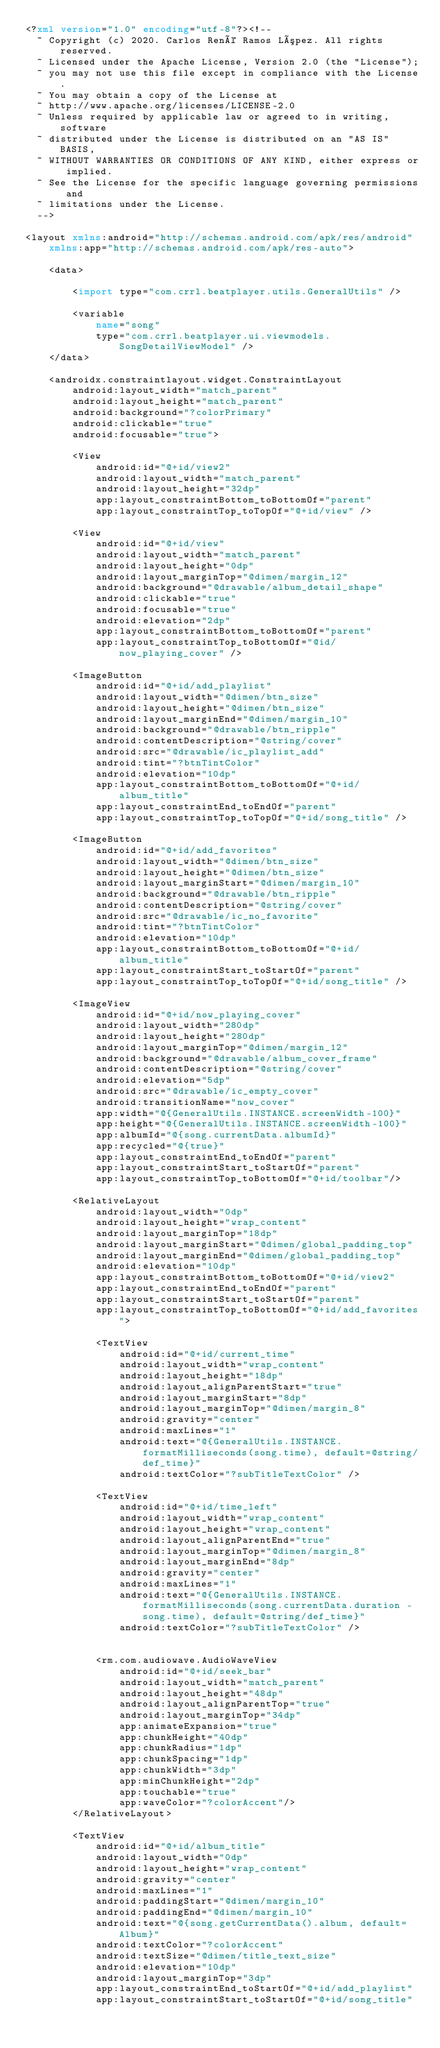Convert code to text. <code><loc_0><loc_0><loc_500><loc_500><_XML_><?xml version="1.0" encoding="utf-8"?><!--
  ~ Copyright (c) 2020. Carlos René Ramos López. All rights reserved.
  ~ Licensed under the Apache License, Version 2.0 (the "License");
  ~ you may not use this file except in compliance with the License.
  ~ You may obtain a copy of the License at
  ~ http://www.apache.org/licenses/LICENSE-2.0
  ~ Unless required by applicable law or agreed to in writing, software
  ~ distributed under the License is distributed on an "AS IS" BASIS,
  ~ WITHOUT WARRANTIES OR CONDITIONS OF ANY KIND, either express or implied.
  ~ See the License for the specific language governing permissions and
  ~ limitations under the License.
  -->

<layout xmlns:android="http://schemas.android.com/apk/res/android"
    xmlns:app="http://schemas.android.com/apk/res-auto">

    <data>

        <import type="com.crrl.beatplayer.utils.GeneralUtils" />

        <variable
            name="song"
            type="com.crrl.beatplayer.ui.viewmodels.SongDetailViewModel" />
    </data>

    <androidx.constraintlayout.widget.ConstraintLayout
        android:layout_width="match_parent"
        android:layout_height="match_parent"
        android:background="?colorPrimary"
        android:clickable="true"
        android:focusable="true">

        <View
            android:id="@+id/view2"
            android:layout_width="match_parent"
            android:layout_height="32dp"
            app:layout_constraintBottom_toBottomOf="parent"
            app:layout_constraintTop_toTopOf="@+id/view" />

        <View
            android:id="@+id/view"
            android:layout_width="match_parent"
            android:layout_height="0dp"
            android:layout_marginTop="@dimen/margin_12"
            android:background="@drawable/album_detail_shape"
            android:clickable="true"
            android:focusable="true"
            android:elevation="2dp"
            app:layout_constraintBottom_toBottomOf="parent"
            app:layout_constraintTop_toBottomOf="@id/now_playing_cover" />

        <ImageButton
            android:id="@+id/add_playlist"
            android:layout_width="@dimen/btn_size"
            android:layout_height="@dimen/btn_size"
            android:layout_marginEnd="@dimen/margin_10"
            android:background="@drawable/btn_ripple"
            android:contentDescription="@string/cover"
            android:src="@drawable/ic_playlist_add"
            android:tint="?btnTintColor"
            android:elevation="10dp"
            app:layout_constraintBottom_toBottomOf="@+id/album_title"
            app:layout_constraintEnd_toEndOf="parent"
            app:layout_constraintTop_toTopOf="@+id/song_title" />

        <ImageButton
            android:id="@+id/add_favorites"
            android:layout_width="@dimen/btn_size"
            android:layout_height="@dimen/btn_size"
            android:layout_marginStart="@dimen/margin_10"
            android:background="@drawable/btn_ripple"
            android:contentDescription="@string/cover"
            android:src="@drawable/ic_no_favorite"
            android:tint="?btnTintColor"
            android:elevation="10dp"
            app:layout_constraintBottom_toBottomOf="@+id/album_title"
            app:layout_constraintStart_toStartOf="parent"
            app:layout_constraintTop_toTopOf="@+id/song_title" />

        <ImageView
            android:id="@+id/now_playing_cover"
            android:layout_width="280dp"
            android:layout_height="280dp"
            android:layout_marginTop="@dimen/margin_12"
            android:background="@drawable/album_cover_frame"
            android:contentDescription="@string/cover"
            android:elevation="5dp"
            android:src="@drawable/ic_empty_cover"
            android:transitionName="now_cover"
            app:width="@{GeneralUtils.INSTANCE.screenWidth-100}"
            app:height="@{GeneralUtils.INSTANCE.screenWidth-100}"
            app:albumId="@{song.currentData.albumId}"
            app:recycled="@{true}"
            app:layout_constraintEnd_toEndOf="parent"
            app:layout_constraintStart_toStartOf="parent"
            app:layout_constraintTop_toBottomOf="@+id/toolbar"/>

        <RelativeLayout
            android:layout_width="0dp"
            android:layout_height="wrap_content"
            android:layout_marginTop="18dp"
            android:layout_marginStart="@dimen/global_padding_top"
            android:layout_marginEnd="@dimen/global_padding_top"
            android:elevation="10dp"
            app:layout_constraintBottom_toBottomOf="@+id/view2"
            app:layout_constraintEnd_toEndOf="parent"
            app:layout_constraintStart_toStartOf="parent"
            app:layout_constraintTop_toBottomOf="@+id/add_favorites">

            <TextView
                android:id="@+id/current_time"
                android:layout_width="wrap_content"
                android:layout_height="18dp"
                android:layout_alignParentStart="true"
                android:layout_marginStart="8dp"
                android:layout_marginTop="@dimen/margin_8"
                android:gravity="center"
                android:maxLines="1"
                android:text="@{GeneralUtils.INSTANCE.formatMilliseconds(song.time), default=@string/def_time}"
                android:textColor="?subTitleTextColor" />

            <TextView
                android:id="@+id/time_left"
                android:layout_width="wrap_content"
                android:layout_height="wrap_content"
                android:layout_alignParentEnd="true"
                android:layout_marginTop="@dimen/margin_8"
                android:layout_marginEnd="8dp"
                android:gravity="center"
                android:maxLines="1"
                android:text="@{GeneralUtils.INSTANCE.formatMilliseconds(song.currentData.duration - song.time), default=@string/def_time}"
                android:textColor="?subTitleTextColor" />


            <rm.com.audiowave.AudioWaveView
                android:id="@+id/seek_bar"
                android:layout_width="match_parent"
                android:layout_height="48dp"
                android:layout_alignParentTop="true"
                android:layout_marginTop="34dp"
                app:animateExpansion="true"
                app:chunkHeight="40dp"
                app:chunkRadius="1dp"
                app:chunkSpacing="1dp"
                app:chunkWidth="3dp"
                app:minChunkHeight="2dp"
                app:touchable="true"
                app:waveColor="?colorAccent"/>
        </RelativeLayout>

        <TextView
            android:id="@+id/album_title"
            android:layout_width="0dp"
            android:layout_height="wrap_content"
            android:gravity="center"
            android:maxLines="1"
            android:paddingStart="@dimen/margin_10"
            android:paddingEnd="@dimen/margin_10"
            android:text="@{song.getCurrentData().album, default=Album}"
            android:textColor="?colorAccent"
            android:textSize="@dimen/title_text_size"
            android:elevation="10dp"
            android:layout_marginTop="3dp"
            app:layout_constraintEnd_toStartOf="@+id/add_playlist"
            app:layout_constraintStart_toStartOf="@+id/song_title"</code> 